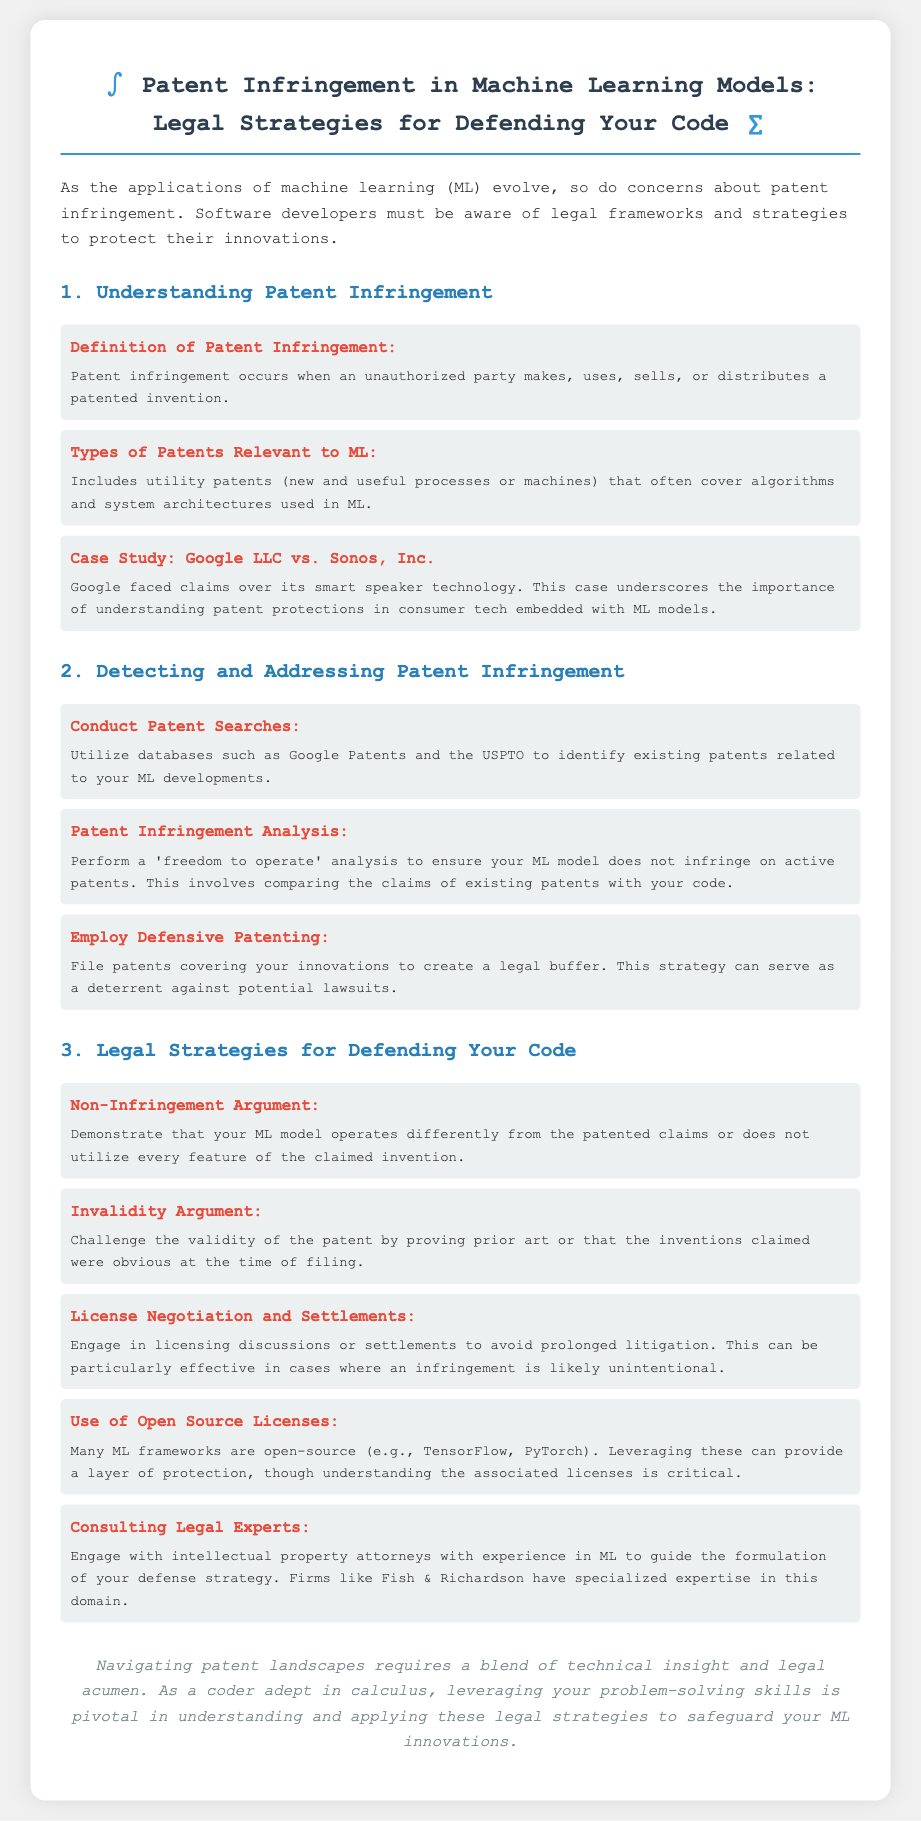What is the definition of patent infringement? The definition is provided in the document under the section "Understanding Patent Infringement."
Answer: Unauthorized party makes, uses, sells, or distributes a patented invention What types of patents are relevant to machine learning? The types of patents are described in the same section, mentioning their implications for ML.
Answer: Utility patents What case study is mentioned in the brief? The document provides a case study as an example in the "Understanding Patent Infringement" section.
Answer: Google LLC vs. Sonos, Inc What should you conduct to detect patent infringement? The document describes actions to take in the section "Detecting and Addressing Patent Infringement."
Answer: Patent Searches What is a key legal strategy for defending code? This strategy is listed under "Legal Strategies for Defending Your Code."
Answer: Non-Infringement Argument Which attorneys should be consulted for patent issues? The document suggests consulting a specific type of professional in the "Legal Strategies" section.
Answer: Intellectual property attorneys What does the term "freedom to operate" refer to? The document explains this term in the context of patent infringement analysis.
Answer: An analysis to ensure no infringement on active patents What is a method mentioned for negotiation in patent disputes? The document outlines this method in the section on legal strategies.
Answer: License Negotiation and Settlements What is a significant focus of the conclusion? The conclusion summarizes the approach needed for navigating patent landscapes in relation to the document's topic.
Answer: Blend of technical insight and legal acumen 